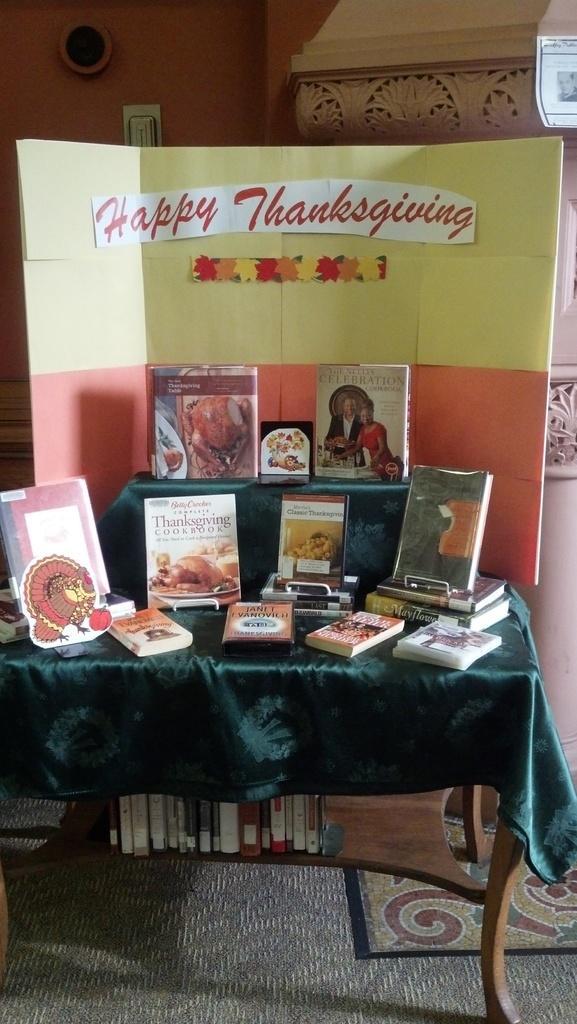How would you summarize this image in a sentence or two? Here in this picture we can see number of books present on the table and below the table also we can see some books present in the racks and we can see a cardboard designed and something pasted on it. 